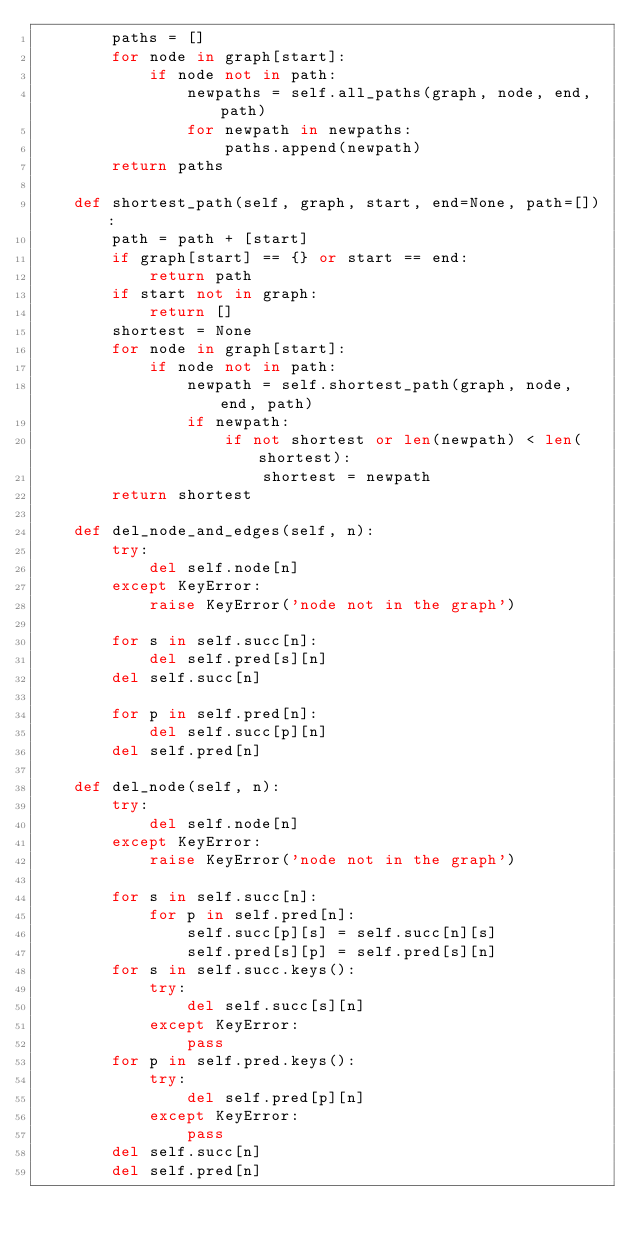Convert code to text. <code><loc_0><loc_0><loc_500><loc_500><_Python_>        paths = []
        for node in graph[start]:
            if node not in path:
                newpaths = self.all_paths(graph, node, end, path)
                for newpath in newpaths:
                    paths.append(newpath)
        return paths

    def shortest_path(self, graph, start, end=None, path=[]):
        path = path + [start]
        if graph[start] == {} or start == end:
            return path
        if start not in graph:
            return []
        shortest = None
        for node in graph[start]:
            if node not in path:
                newpath = self.shortest_path(graph, node, end, path)
                if newpath:
                    if not shortest or len(newpath) < len(shortest):
                        shortest = newpath
        return shortest

    def del_node_and_edges(self, n):
        try:
            del self.node[n]
        except KeyError:
            raise KeyError('node not in the graph')

        for s in self.succ[n]:
            del self.pred[s][n]
        del self.succ[n]

        for p in self.pred[n]:
            del self.succ[p][n]
        del self.pred[n]

    def del_node(self, n):
        try:
            del self.node[n]
        except KeyError:
            raise KeyError('node not in the graph')

        for s in self.succ[n]:
            for p in self.pred[n]:
                self.succ[p][s] = self.succ[n][s]
                self.pred[s][p] = self.pred[s][n]
        for s in self.succ.keys():
            try:
                del self.succ[s][n]
            except KeyError:
                pass
        for p in self.pred.keys():
            try:
                del self.pred[p][n]
            except KeyError:
                pass
        del self.succ[n]
        del self.pred[n]
</code> 